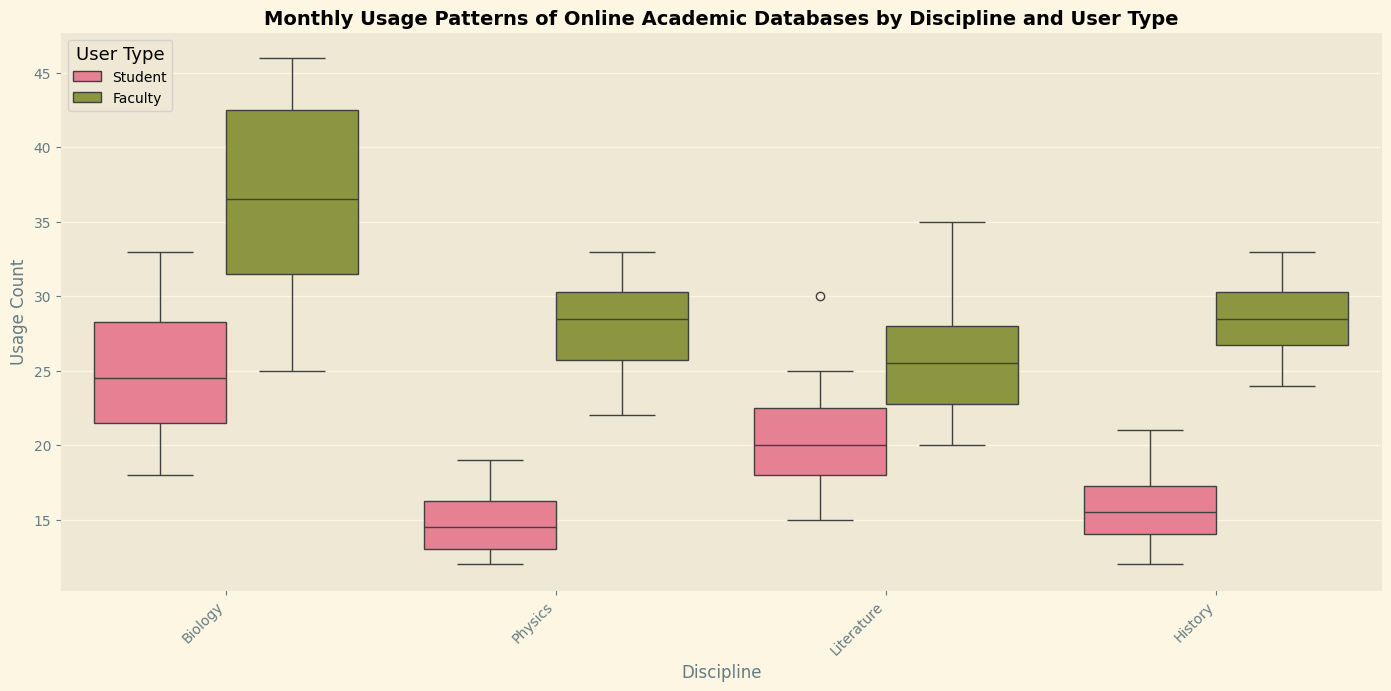What is the median usage count for students in Physics? To find the median, one would look at the boxplot for students in Physics. The line within the box represents the median value.
Answer: 14 In which discipline do faculty members have the highest maximum usage count? For this, check the highest whisker (top line) extending from the boxes for faculty members in each discipline. The highest one is the highest maximum usage count.
Answer: Biology Compare the median usage count for students in Biology and History. Which one is higher? Identify the median values (the lines inside the box) for students in both Biology and History and compare them.
Answer: Biology's median is higher Which user type in Literature has the greater range in usage count? Calculate the range by looking at the distance between the top and bottom whiskers for both students and faculty in Literature. Compare the ranges.
Answer: Faculty What's the interquartile range (IQR) for student usage in Literature? The IQR is the range between the first quartile (bottom of the box) and third quartile (top of the box) in the boxplot for students in Literature.
Answer: 7 (25-18) By comparing the boxes' lengths, which discipline shows the most variability in usage count for faculty members? Determine variability by looking at the length of the boxes. The longer the box, the more variability.
Answer: Biology Based on the boxplots, which user type generally has higher usage counts across all disciplines? Compare the median lines of usage counts for students and faculty across all disciplines to see which are generally higher.
Answer: Faculty What is the difference in median usage count between students and faculty in History? Find the median values for both students and faculty in History from the boxplot and subtract the student median from the faculty median.
Answer: 13 (28-15) Which month might be an outlier for student usage in Physics? Look at the dots outside the whiskers in the student usage boxplot for Physics, as they represent outliers.
Answer: February 